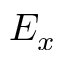Convert formula to latex. <formula><loc_0><loc_0><loc_500><loc_500>E _ { x }</formula> 